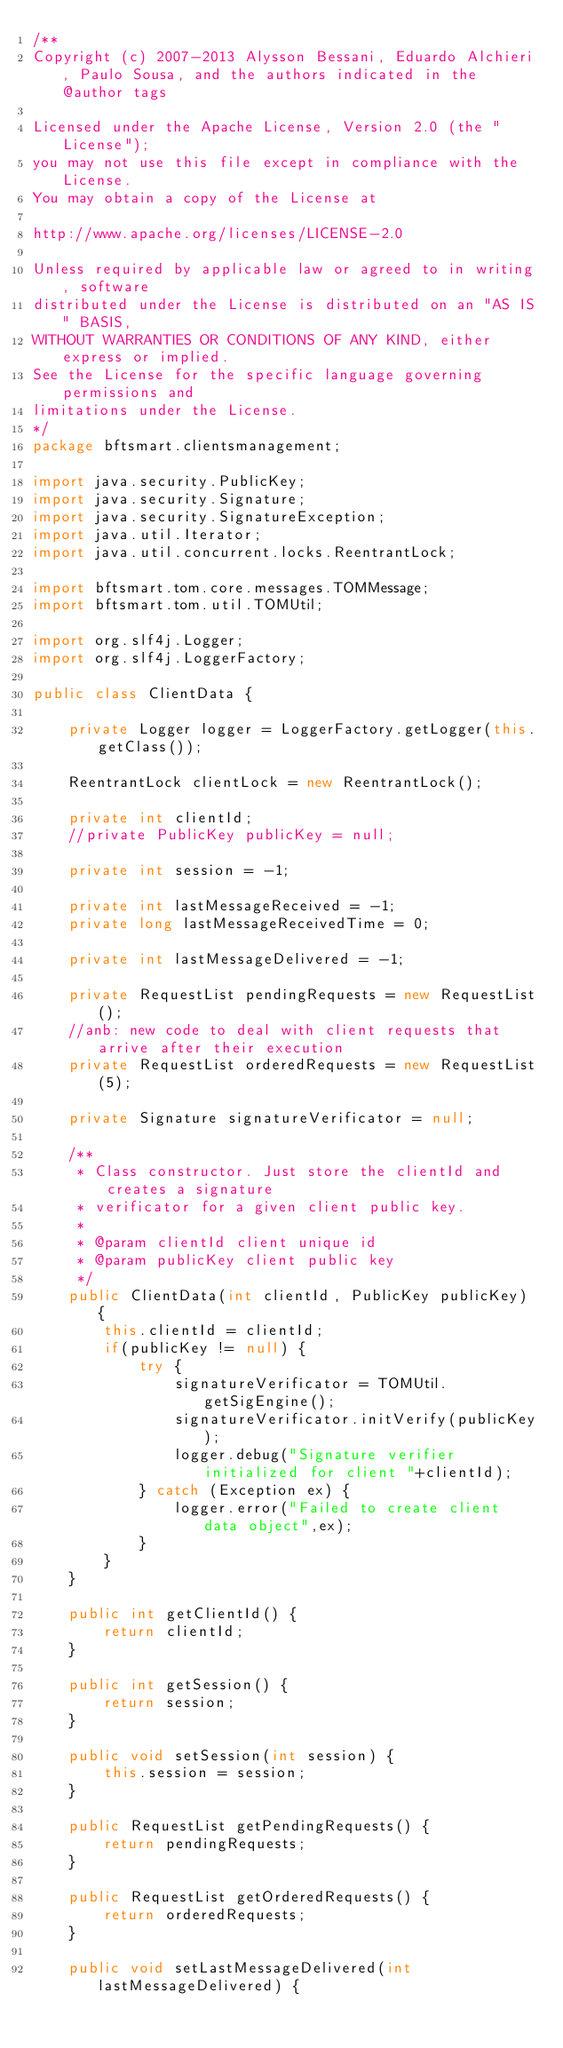<code> <loc_0><loc_0><loc_500><loc_500><_Java_>/**
Copyright (c) 2007-2013 Alysson Bessani, Eduardo Alchieri, Paulo Sousa, and the authors indicated in the @author tags

Licensed under the Apache License, Version 2.0 (the "License");
you may not use this file except in compliance with the License.
You may obtain a copy of the License at

http://www.apache.org/licenses/LICENSE-2.0

Unless required by applicable law or agreed to in writing, software
distributed under the License is distributed on an "AS IS" BASIS,
WITHOUT WARRANTIES OR CONDITIONS OF ANY KIND, either express or implied.
See the License for the specific language governing permissions and
limitations under the License.
*/
package bftsmart.clientsmanagement;

import java.security.PublicKey;
import java.security.Signature;
import java.security.SignatureException;
import java.util.Iterator;
import java.util.concurrent.locks.ReentrantLock;

import bftsmart.tom.core.messages.TOMMessage;
import bftsmart.tom.util.TOMUtil;

import org.slf4j.Logger;
import org.slf4j.LoggerFactory;

public class ClientData {
    
    private Logger logger = LoggerFactory.getLogger(this.getClass());

    ReentrantLock clientLock = new ReentrantLock();

    private int clientId;
    //private PublicKey publicKey = null;

    private int session = -1;

    private int lastMessageReceived = -1;
    private long lastMessageReceivedTime = 0;

    private int lastMessageDelivered = -1;

    private RequestList pendingRequests = new RequestList();
    //anb: new code to deal with client requests that arrive after their execution
    private RequestList orderedRequests = new RequestList(5);

    private Signature signatureVerificator = null;
    
    /**
     * Class constructor. Just store the clientId and creates a signature
     * verificator for a given client public key.
     *
     * @param clientId client unique id
     * @param publicKey client public key
     */
    public ClientData(int clientId, PublicKey publicKey) {
        this.clientId = clientId;
        if(publicKey != null) {
            try {
                signatureVerificator = TOMUtil.getSigEngine();
                signatureVerificator.initVerify(publicKey);
                logger.debug("Signature verifier initialized for client "+clientId);
            } catch (Exception ex) {
                logger.error("Failed to create client data object",ex);
            }
        }
    }

    public int getClientId() {
        return clientId;
    }

    public int getSession() {
        return session;
    }

    public void setSession(int session) {
        this.session = session;
    }

    public RequestList getPendingRequests() {
        return pendingRequests;
    }

    public RequestList getOrderedRequests() {
        return orderedRequests;
    }

    public void setLastMessageDelivered(int lastMessageDelivered) {</code> 